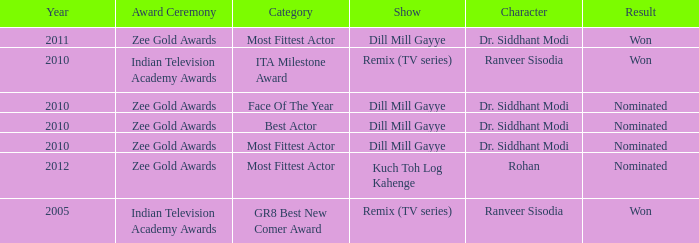Which show has a character of Rohan? Kuch Toh Log Kahenge. 